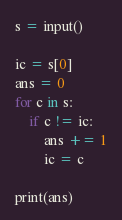Convert code to text. <code><loc_0><loc_0><loc_500><loc_500><_Python_>s = input()

ic = s[0]
ans = 0
for c in s:
    if c != ic:
        ans += 1
        ic = c

print(ans)</code> 